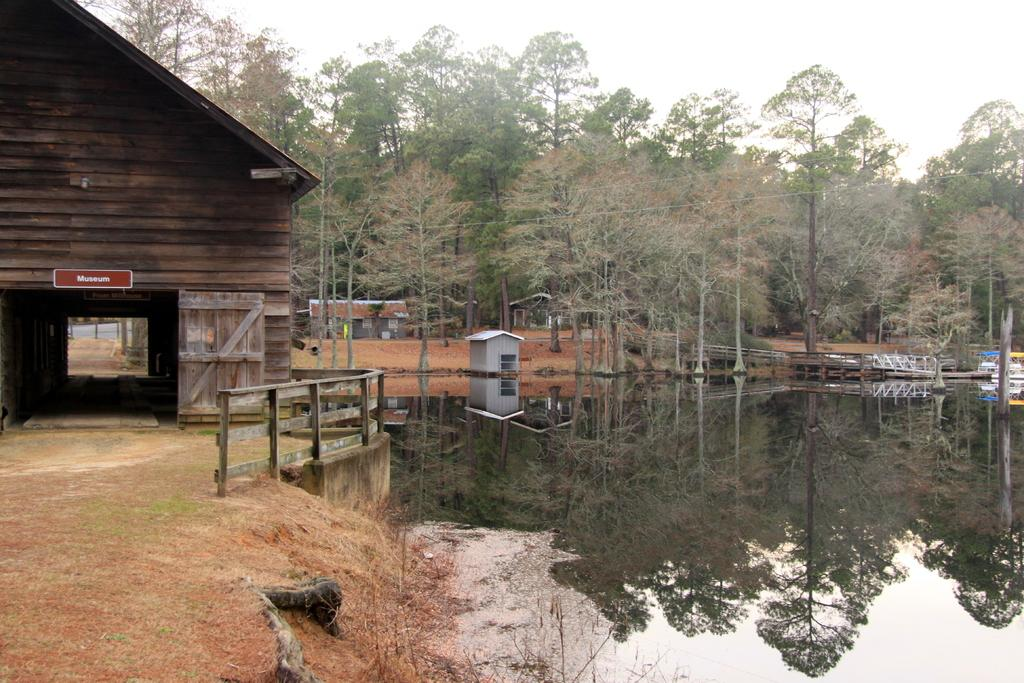What type of natural feature is present in the image? There is a water body in the image. What type of structure can be seen near the water body? There is a wooden house in the image. What is used to enclose or separate areas in the image? There is a fence in the image. What is used for accessing the water body in the image? There is a dock in the image. What type of vegetation is present in the image? There are trees in the image. What is visible at the top of the image? The sky is visible at the top of the image. What type of camera is being used to take the picture of the surprise bee in the image? There is no camera, surprise, or bee present in the image. 